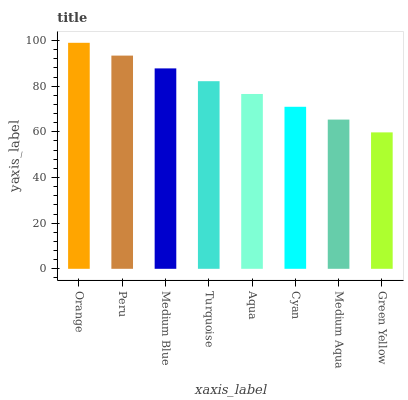Is Green Yellow the minimum?
Answer yes or no. Yes. Is Orange the maximum?
Answer yes or no. Yes. Is Peru the minimum?
Answer yes or no. No. Is Peru the maximum?
Answer yes or no. No. Is Orange greater than Peru?
Answer yes or no. Yes. Is Peru less than Orange?
Answer yes or no. Yes. Is Peru greater than Orange?
Answer yes or no. No. Is Orange less than Peru?
Answer yes or no. No. Is Turquoise the high median?
Answer yes or no. Yes. Is Aqua the low median?
Answer yes or no. Yes. Is Medium Aqua the high median?
Answer yes or no. No. Is Peru the low median?
Answer yes or no. No. 